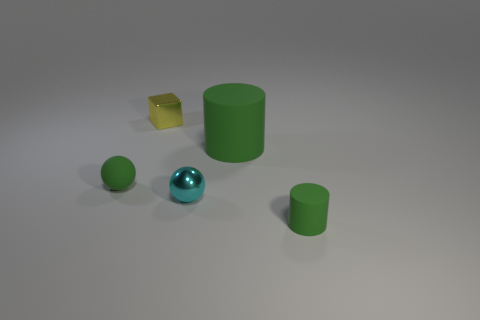Add 2 purple metal spheres. How many objects exist? 7 Subtract 1 cylinders. How many cylinders are left? 1 Subtract 0 blue blocks. How many objects are left? 5 Subtract all cylinders. How many objects are left? 3 Subtract all big brown balls. Subtract all balls. How many objects are left? 3 Add 2 tiny green matte spheres. How many tiny green matte spheres are left? 3 Add 2 small yellow metallic things. How many small yellow metallic things exist? 3 